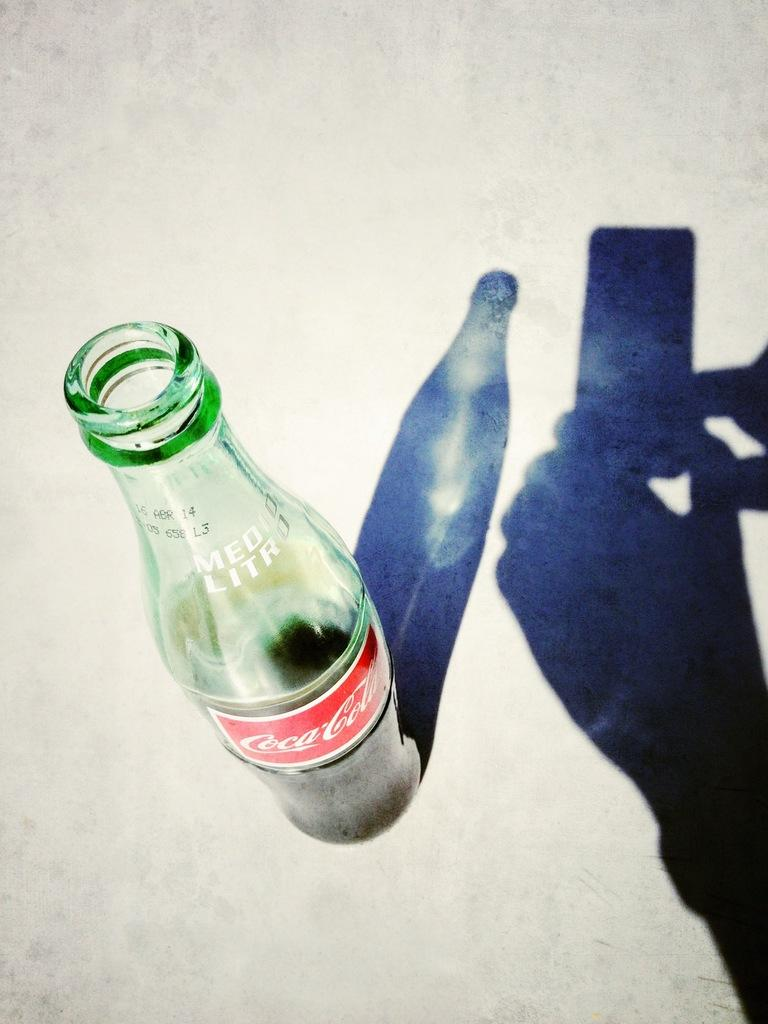What color is the bottle in the image? The bottle in the image is green. What else is visible in the image besides the bottle? There is a shadow of a mobile held with hands and the bottle in the image. What type of doctor is examining the bottle in the image? There is no doctor present in the image, and the bottle is not being examined by anyone. 